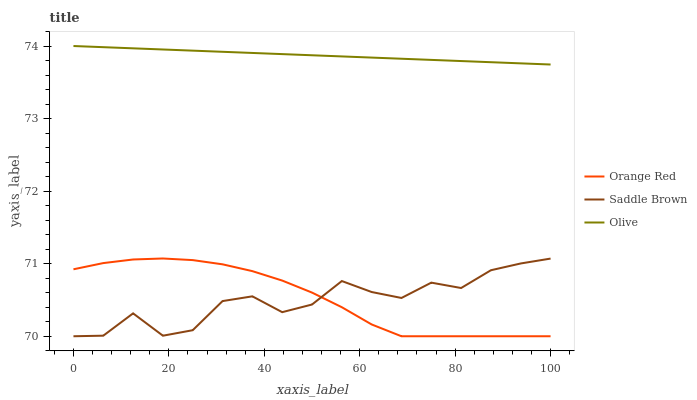Does Saddle Brown have the minimum area under the curve?
Answer yes or no. Yes. Does Olive have the maximum area under the curve?
Answer yes or no. Yes. Does Orange Red have the minimum area under the curve?
Answer yes or no. No. Does Orange Red have the maximum area under the curve?
Answer yes or no. No. Is Olive the smoothest?
Answer yes or no. Yes. Is Saddle Brown the roughest?
Answer yes or no. Yes. Is Orange Red the smoothest?
Answer yes or no. No. Is Orange Red the roughest?
Answer yes or no. No. Does Orange Red have the lowest value?
Answer yes or no. Yes. Does Olive have the highest value?
Answer yes or no. Yes. Does Orange Red have the highest value?
Answer yes or no. No. Is Orange Red less than Olive?
Answer yes or no. Yes. Is Olive greater than Saddle Brown?
Answer yes or no. Yes. Does Orange Red intersect Saddle Brown?
Answer yes or no. Yes. Is Orange Red less than Saddle Brown?
Answer yes or no. No. Is Orange Red greater than Saddle Brown?
Answer yes or no. No. Does Orange Red intersect Olive?
Answer yes or no. No. 